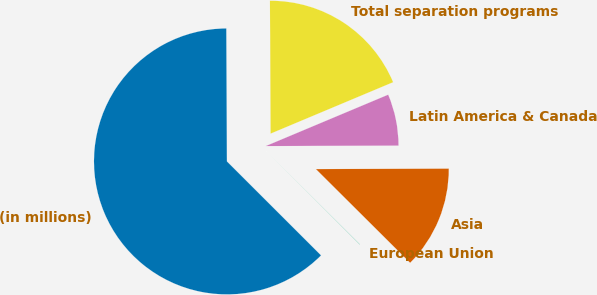<chart> <loc_0><loc_0><loc_500><loc_500><pie_chart><fcel>(in millions)<fcel>European Union<fcel>Asia<fcel>Latin America & Canada<fcel>Total separation programs<nl><fcel>62.43%<fcel>0.03%<fcel>12.51%<fcel>6.27%<fcel>18.75%<nl></chart> 